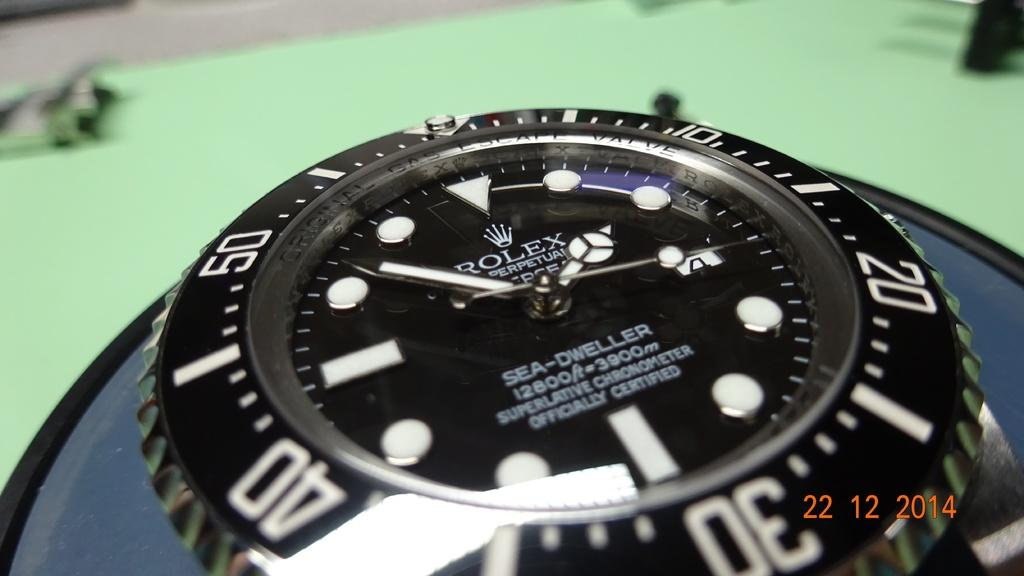Provide a one-sentence caption for the provided image. A rolex watch displaying the time of 1:52. 